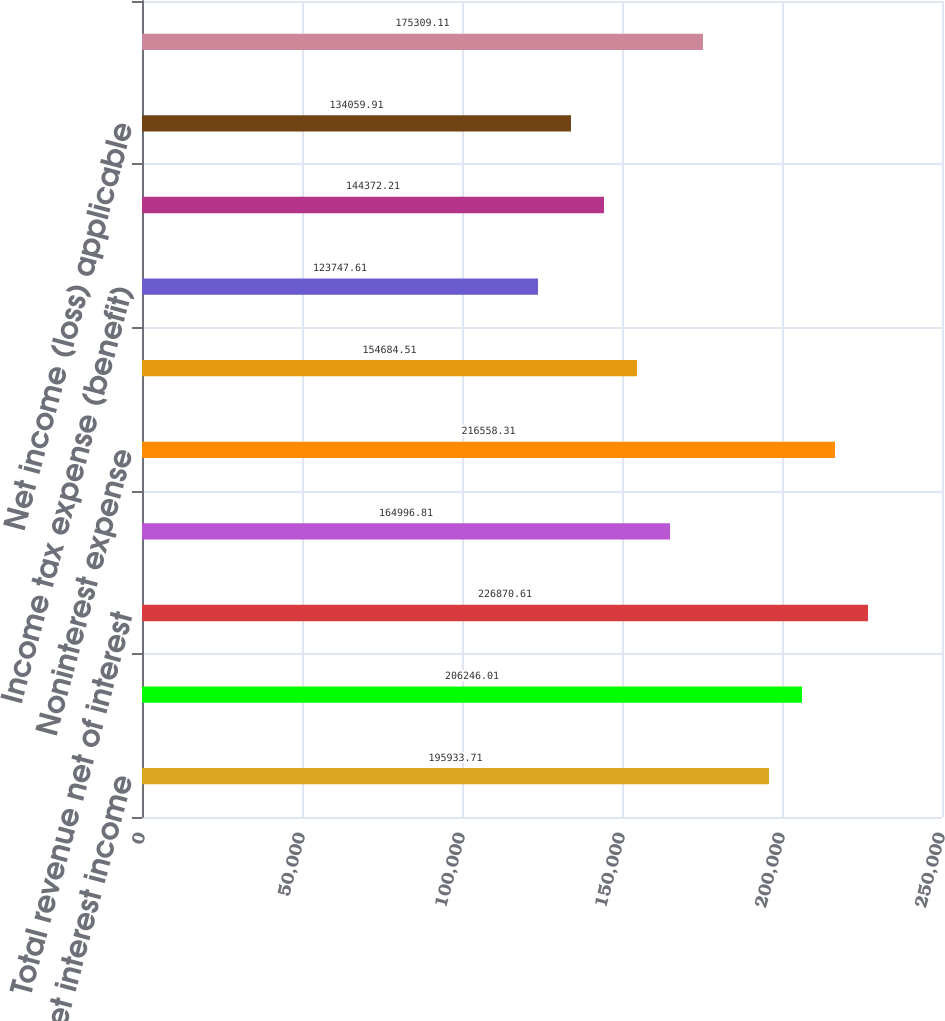Convert chart to OTSL. <chart><loc_0><loc_0><loc_500><loc_500><bar_chart><fcel>Net interest income<fcel>Noninterest income<fcel>Total revenue net of interest<fcel>Provision for credit losses<fcel>Noninterest expense<fcel>Income (loss) before income<fcel>Income tax expense (benefit)<fcel>Net income<fcel>Net income (loss) applicable<fcel>Average common shares issued<nl><fcel>195934<fcel>206246<fcel>226871<fcel>164997<fcel>216558<fcel>154685<fcel>123748<fcel>144372<fcel>134060<fcel>175309<nl></chart> 